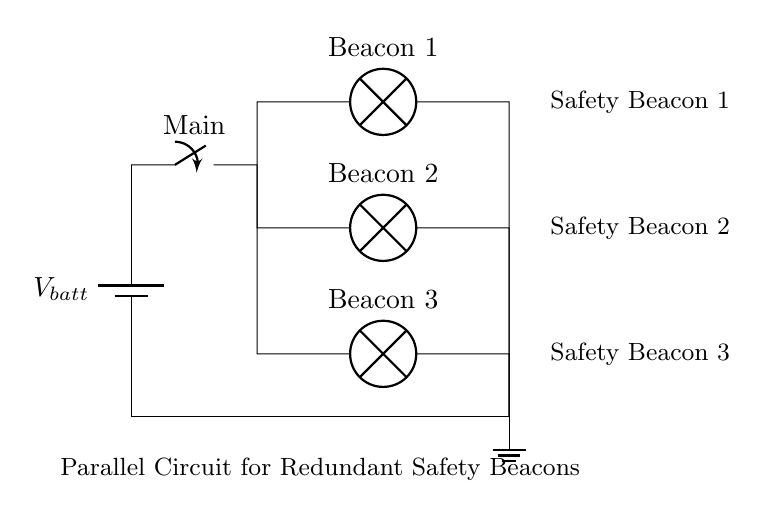What type of circuit configuration is shown? The circuit features multiple branches that operate independently, functioning simultaneously, which is characteristic of a parallel circuit.
Answer: Parallel circuit How many safety beacons are present in the circuit? There are three distinct lamps labeled as beacons in the circuit, specifically listed as Beacon 1, Beacon 2, and Beacon 3.
Answer: Three What is the role of the main switch? The main switch allows or interrupts the flow of current to all beacons simultaneously, thus controlling the entire circuit’s operation.
Answer: Control current flow What happens if one safety beacon fails? In a parallel configuration, the remaining beacons continue to operate unaffected, ensuring redundancy and safety for the user.
Answer: Remaining beacons stay operational What is the voltage applied to each beacon? Each beacon experiences the full voltage from the battery source, as this is a parallel circuit where the voltage across components is equal to the source voltage.
Answer: Battery voltage How does this circuit enhance safety for paragliders? The redundant nature of the safety beacons ensures continuous signaling even if one or more beacons fail, maintaining visibility to others.
Answer: Ensures continuous signaling 